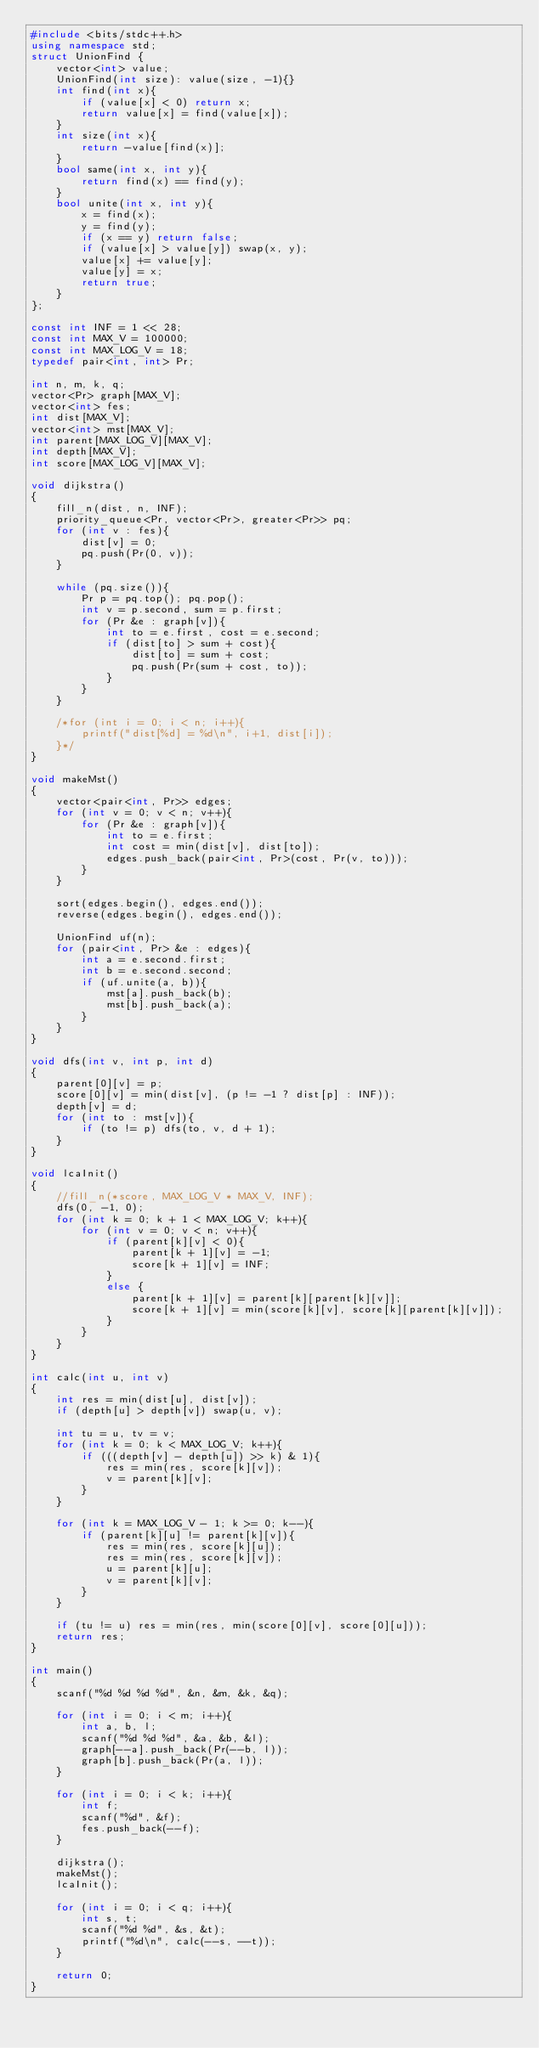<code> <loc_0><loc_0><loc_500><loc_500><_C++_>#include <bits/stdc++.h>
using namespace std;
struct UnionFind {
	vector<int> value;
	UnionFind(int size): value(size, -1){}
	int find(int x){
		if (value[x] < 0) return x;
		return value[x] = find(value[x]);
	}
	int size(int x){
		return -value[find(x)];
	}
	bool same(int x, int y){
		return find(x) == find(y);
	}
	bool unite(int x, int y){
		x = find(x);
		y = find(y);
		if (x == y) return false;
		if (value[x] > value[y]) swap(x, y);
		value[x] += value[y];
		value[y] = x;
		return true;
	}
};

const int INF = 1 << 28;
const int MAX_V = 100000;
const int MAX_LOG_V = 18;
typedef pair<int, int> Pr;

int n, m, k, q;
vector<Pr> graph[MAX_V];
vector<int> fes;
int dist[MAX_V];
vector<int> mst[MAX_V];
int parent[MAX_LOG_V][MAX_V];
int depth[MAX_V];
int score[MAX_LOG_V][MAX_V];

void dijkstra()
{
	fill_n(dist, n, INF);
	priority_queue<Pr, vector<Pr>, greater<Pr>> pq;
	for (int v : fes){
		dist[v] = 0;
		pq.push(Pr(0, v));
	}
	
	while (pq.size()){
		Pr p = pq.top(); pq.pop();
		int v = p.second, sum = p.first;
		for (Pr &e : graph[v]){
			int to = e.first, cost = e.second;
			if (dist[to] > sum + cost){
				dist[to] = sum + cost;
				pq.push(Pr(sum + cost, to));
			}
		}
	}
	
	/*for (int i = 0; i < n; i++){
		printf("dist[%d] = %d\n", i+1, dist[i]);
	}*/
}

void makeMst()
{
	vector<pair<int, Pr>> edges;
	for (int v = 0; v < n; v++){
		for (Pr &e : graph[v]){
			int to = e.first;
			int cost = min(dist[v], dist[to]);
			edges.push_back(pair<int, Pr>(cost, Pr(v, to)));
		}
	}
	
	sort(edges.begin(), edges.end());
	reverse(edges.begin(), edges.end());
	
	UnionFind uf(n);
	for (pair<int, Pr> &e : edges){
		int a = e.second.first;
		int b = e.second.second;
		if (uf.unite(a, b)){
			mst[a].push_back(b);
			mst[b].push_back(a);
		}
	}
}

void dfs(int v, int p, int d)
{
	parent[0][v] = p;
	score[0][v] = min(dist[v], (p != -1 ? dist[p] : INF));
	depth[v] = d;
	for (int to : mst[v]){
		if (to != p) dfs(to, v, d + 1);
	}
}

void lcaInit()
{
	//fill_n(*score, MAX_LOG_V * MAX_V, INF);
	dfs(0, -1, 0);
	for (int k = 0; k + 1 < MAX_LOG_V; k++){
		for (int v = 0; v < n; v++){
			if (parent[k][v] < 0){
				parent[k + 1][v] = -1;
				score[k + 1][v] = INF;
			}
			else {
				parent[k + 1][v] = parent[k][parent[k][v]];
				score[k + 1][v] = min(score[k][v], score[k][parent[k][v]]);
			}
		}
	}
}

int calc(int u, int v)
{
	int res = min(dist[u], dist[v]);
	if (depth[u] > depth[v]) swap(u, v);
	
	int tu = u, tv = v;
	for (int k = 0; k < MAX_LOG_V; k++){
		if (((depth[v] - depth[u]) >> k) & 1){
			res = min(res, score[k][v]);
			v = parent[k][v];
		}
	}
	
	for (int k = MAX_LOG_V - 1; k >= 0; k--){
		if (parent[k][u] != parent[k][v]){
			res = min(res, score[k][u]);
			res = min(res, score[k][v]);
			u = parent[k][u];
			v = parent[k][v];
		}
	}
	
	if (tu != u) res = min(res, min(score[0][v], score[0][u]));
	return res;
}

int main()
{
	scanf("%d %d %d %d", &n, &m, &k, &q);
	
	for (int i = 0; i < m; i++){
		int a, b, l;
		scanf("%d %d %d", &a, &b, &l);
		graph[--a].push_back(Pr(--b, l));
		graph[b].push_back(Pr(a, l));
	}
	
	for (int i = 0; i < k; i++){
		int f;
		scanf("%d", &f);
		fes.push_back(--f);
	}
	
	dijkstra();
	makeMst();
	lcaInit();
	
	for (int i = 0; i < q; i++){
		int s, t;
		scanf("%d %d", &s, &t);
		printf("%d\n", calc(--s, --t));
	}
	
	return 0;
}</code> 